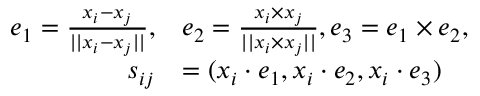Convert formula to latex. <formula><loc_0><loc_0><loc_500><loc_500>\begin{array} { r l } { e _ { 1 } = \frac { x _ { i } - x _ { j } } { | | x _ { i } - x _ { j } | | } , } & { e _ { 2 } = \frac { x _ { i } \times x _ { j } } { | | x _ { i } \times x _ { j } | | } , e _ { 3 } = e _ { 1 } \times e _ { 2 } , } \\ { s _ { i j } } & { = ( x _ { i } \cdot e _ { 1 } , x _ { i } \cdot e _ { 2 } , x _ { i } \cdot e _ { 3 } ) } \end{array}</formula> 